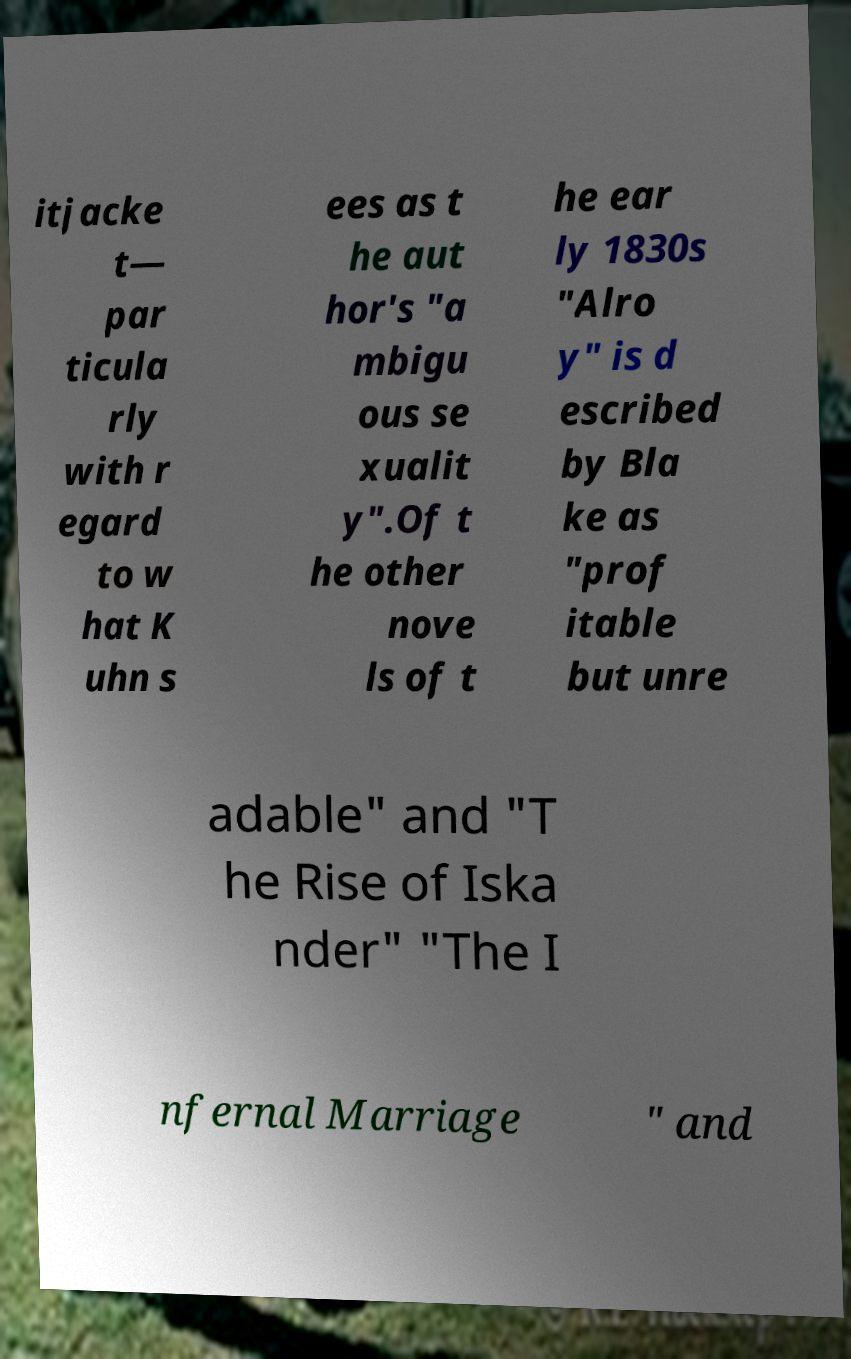Could you assist in decoding the text presented in this image and type it out clearly? itjacke t— par ticula rly with r egard to w hat K uhn s ees as t he aut hor's "a mbigu ous se xualit y".Of t he other nove ls of t he ear ly 1830s "Alro y" is d escribed by Bla ke as "prof itable but unre adable" and "T he Rise of Iska nder" "The I nfernal Marriage " and 